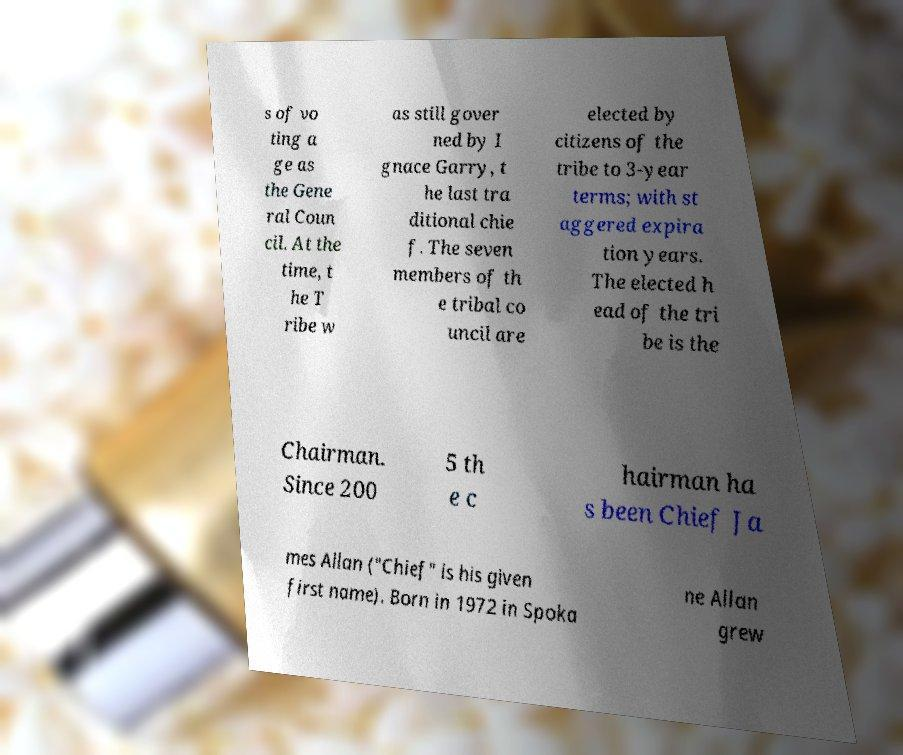Can you accurately transcribe the text from the provided image for me? s of vo ting a ge as the Gene ral Coun cil. At the time, t he T ribe w as still gover ned by I gnace Garry, t he last tra ditional chie f. The seven members of th e tribal co uncil are elected by citizens of the tribe to 3-year terms; with st aggered expira tion years. The elected h ead of the tri be is the Chairman. Since 200 5 th e c hairman ha s been Chief Ja mes Allan ("Chief" is his given first name). Born in 1972 in Spoka ne Allan grew 